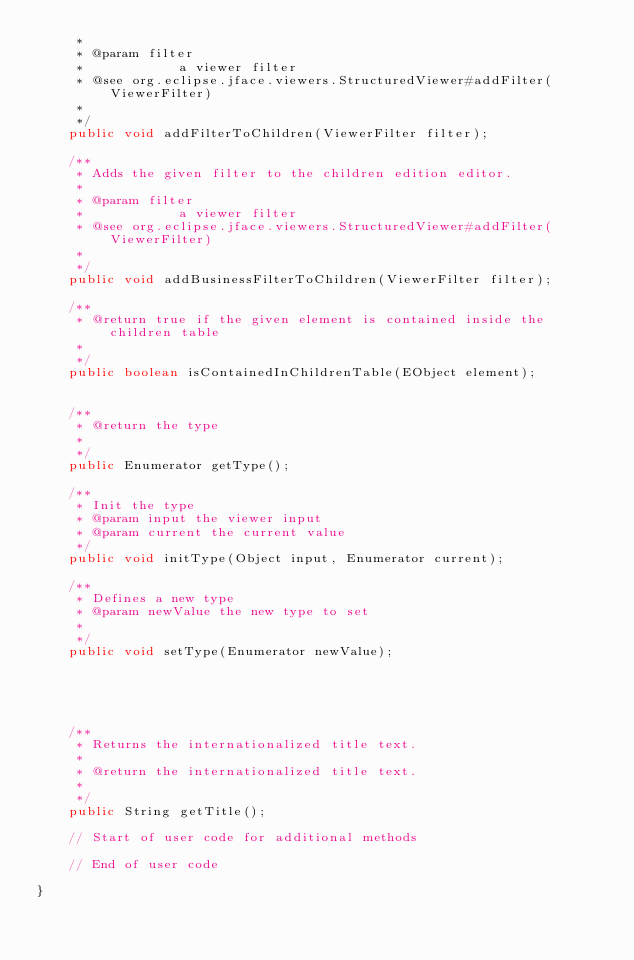<code> <loc_0><loc_0><loc_500><loc_500><_Java_>	 * 
	 * @param filter
	 *            a viewer filter
	 * @see org.eclipse.jface.viewers.StructuredViewer#addFilter(ViewerFilter)
	 * 
	 */
	public void addFilterToChildren(ViewerFilter filter);

	/**
	 * Adds the given filter to the children edition editor.
	 * 
	 * @param filter
	 *            a viewer filter
	 * @see org.eclipse.jface.viewers.StructuredViewer#addFilter(ViewerFilter)
	 * 
	 */
	public void addBusinessFilterToChildren(ViewerFilter filter);

	/**
	 * @return true if the given element is contained inside the children table
	 * 
	 */
	public boolean isContainedInChildrenTable(EObject element);


	/**
	 * @return the type
	 * 
	 */
	public Enumerator getType();

	/**
	 * Init the type
	 * @param input the viewer input
	 * @param current the current value
	 */
	public void initType(Object input, Enumerator current);

	/**
	 * Defines a new type
	 * @param newValue the new type to set
	 * 
	 */
	public void setType(Enumerator newValue);





	/**
	 * Returns the internationalized title text.
	 * 
	 * @return the internationalized title text.
	 * 
	 */
	public String getTitle();

	// Start of user code for additional methods
	
	// End of user code

}
</code> 